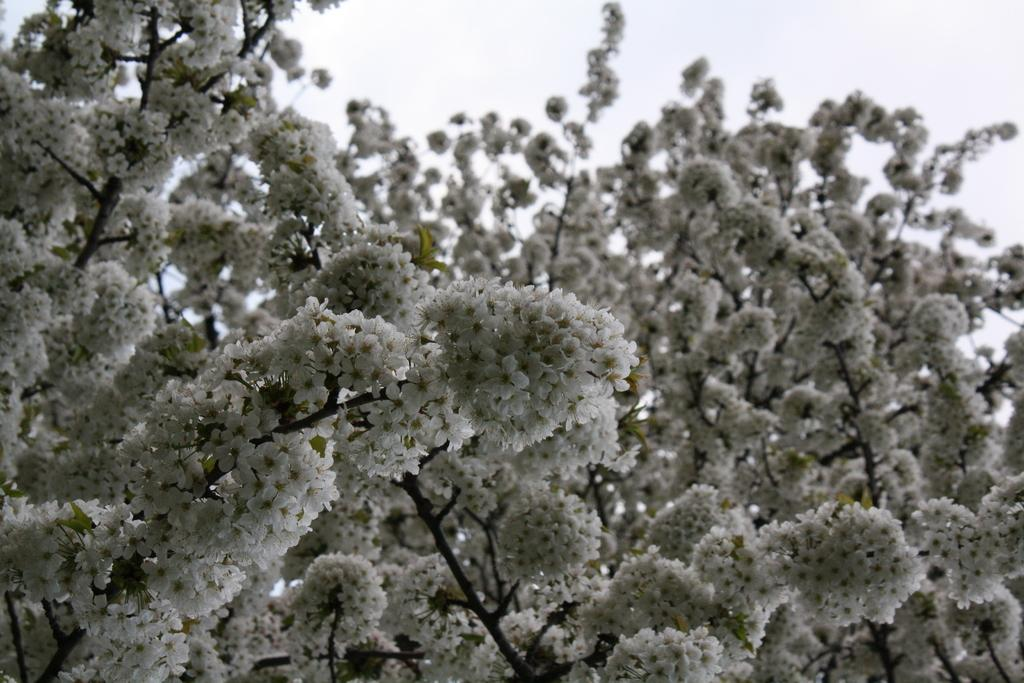What is the main subject of the picture? The main subject of the picture is a tree. What can be observed about the tree's flowers? The tree has many white flowers. Are there any leaves on the tree? Yes, the tree has leaves. How would you describe the sky in the picture? The sky is clear in the picture. How does the tree grip the ground in the image? Trees do not have the ability to grip the ground; they are rooted in the soil. Is there a rainstorm occurring in the image? No, there is no rainstorm depicted in the image; the sky is clear. 